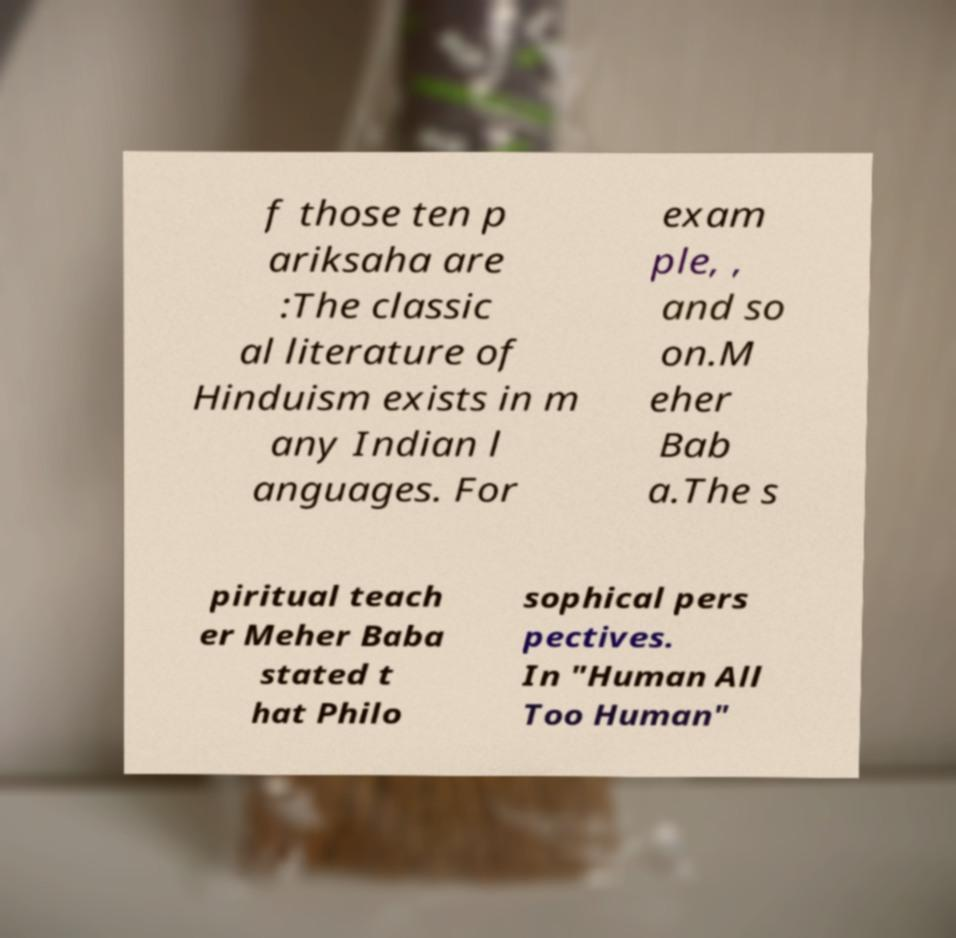There's text embedded in this image that I need extracted. Can you transcribe it verbatim? f those ten p ariksaha are :The classic al literature of Hinduism exists in m any Indian l anguages. For exam ple, , and so on.M eher Bab a.The s piritual teach er Meher Baba stated t hat Philo sophical pers pectives. In "Human All Too Human" 